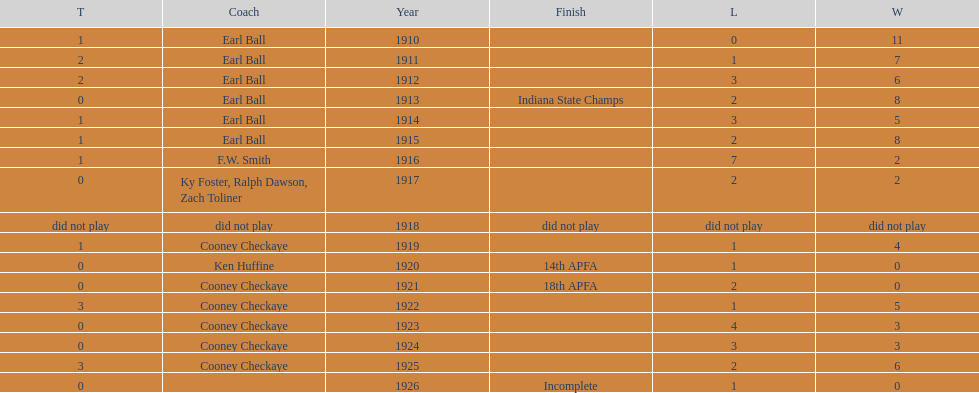Would you be able to parse every entry in this table? {'header': ['T', 'Coach', 'Year', 'Finish', 'L', 'W'], 'rows': [['1', 'Earl Ball', '1910', '', '0', '11'], ['2', 'Earl Ball', '1911', '', '1', '7'], ['2', 'Earl Ball', '1912', '', '3', '6'], ['0', 'Earl Ball', '1913', 'Indiana State Champs', '2', '8'], ['1', 'Earl Ball', '1914', '', '3', '5'], ['1', 'Earl Ball', '1915', '', '2', '8'], ['1', 'F.W. Smith', '1916', '', '7', '2'], ['0', 'Ky Foster, Ralph Dawson, Zach Toliner', '1917', '', '2', '2'], ['did not play', 'did not play', '1918', 'did not play', 'did not play', 'did not play'], ['1', 'Cooney Checkaye', '1919', '', '1', '4'], ['0', 'Ken Huffine', '1920', '14th APFA', '1', '0'], ['0', 'Cooney Checkaye', '1921', '18th APFA', '2', '0'], ['3', 'Cooney Checkaye', '1922', '', '1', '5'], ['0', 'Cooney Checkaye', '1923', '', '4', '3'], ['0', 'Cooney Checkaye', '1924', '', '3', '3'], ['3', 'Cooney Checkaye', '1925', '', '2', '6'], ['0', '', '1926', 'Incomplete', '1', '0']]} In what year were the muncie flyers able to maintain a perfect record? 1910. 